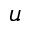<formula> <loc_0><loc_0><loc_500><loc_500>u</formula> 